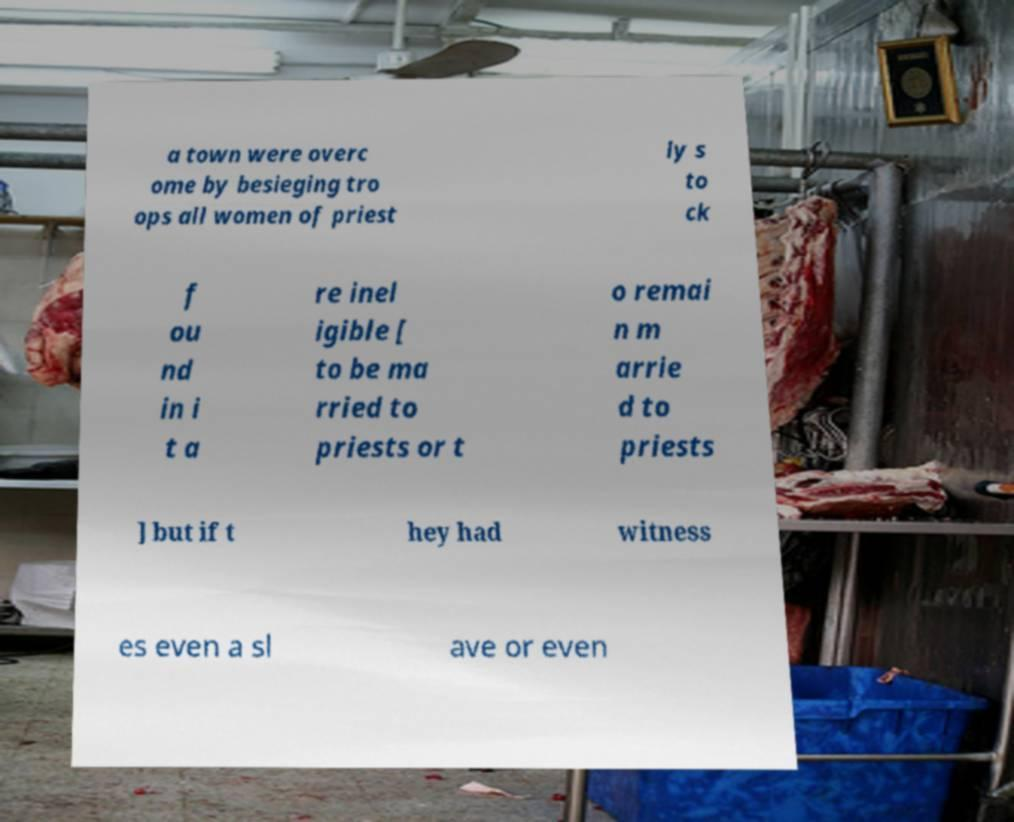Please identify and transcribe the text found in this image. a town were overc ome by besieging tro ops all women of priest ly s to ck f ou nd in i t a re inel igible [ to be ma rried to priests or t o remai n m arrie d to priests ] but if t hey had witness es even a sl ave or even 